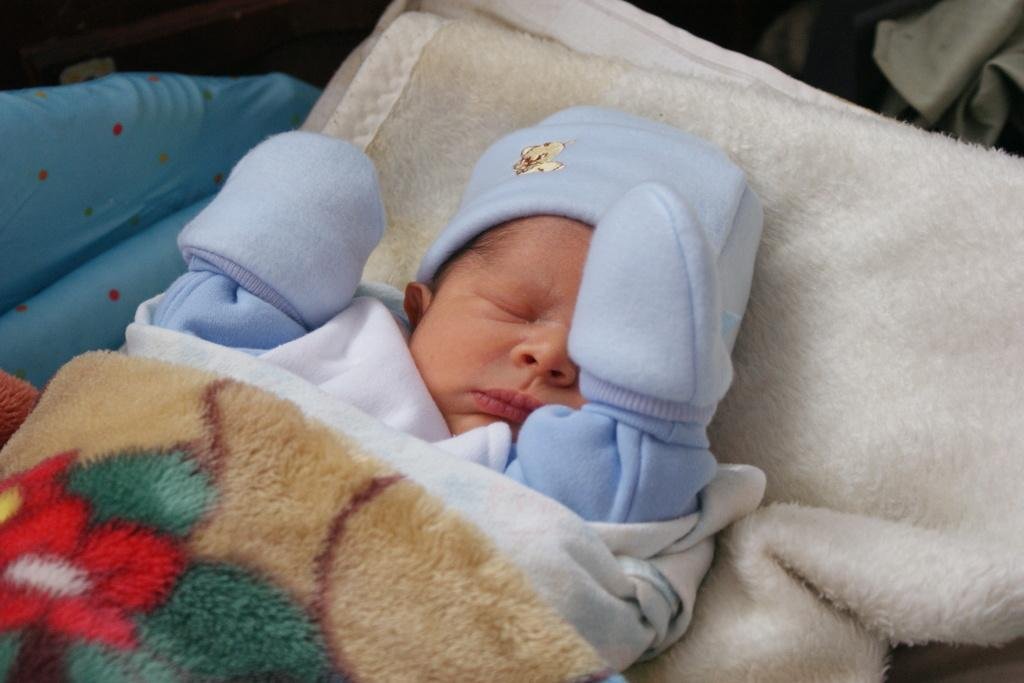What is the main subject of the picture? There is a little baby in the picture. What is the baby wearing? The baby is wearing a blue dress. What is the baby doing in the picture? The baby is sleeping. What is the baby lying on? The baby is lying on a white towel. How is the baby covered in the picture? The baby is covered with a blanket. What type of trains can be seen in the background of the picture? There are no trains visible in the background of the picture; it only features the baby lying on a white towel and covered with a blanket. 